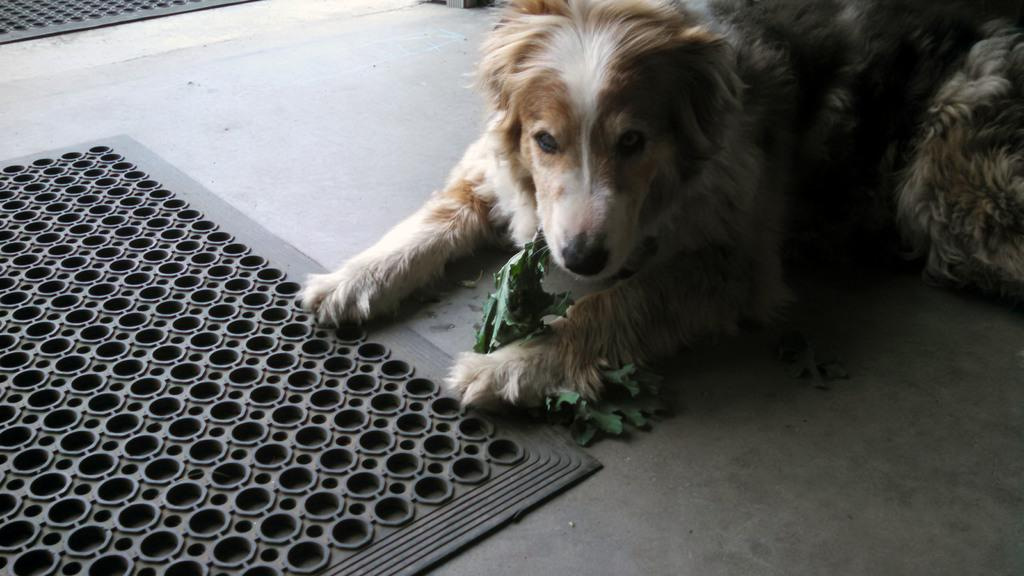What animal is present in the image? There is a dog in the image. What is the dog holding in its mouth? The dog is holding leaves in the image. Can you identify any other objects in the image? Yes, there is a Mars bar in the image. What note is the dog playing on the musical appliance in the image? There is no musical appliance present in the image, and the dog is not playing any notes. 